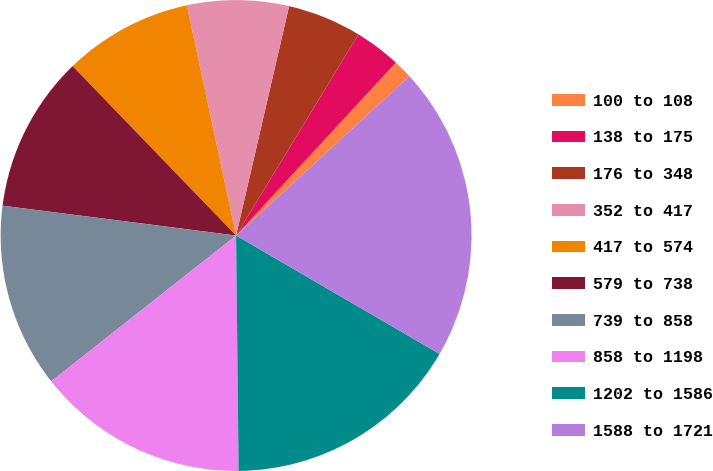Convert chart to OTSL. <chart><loc_0><loc_0><loc_500><loc_500><pie_chart><fcel>100 to 108<fcel>138 to 175<fcel>176 to 348<fcel>352 to 417<fcel>417 to 574<fcel>579 to 738<fcel>739 to 858<fcel>858 to 1198<fcel>1202 to 1586<fcel>1588 to 1721<nl><fcel>1.29%<fcel>3.18%<fcel>5.08%<fcel>6.97%<fcel>8.86%<fcel>10.76%<fcel>12.65%<fcel>14.54%<fcel>16.44%<fcel>20.22%<nl></chart> 